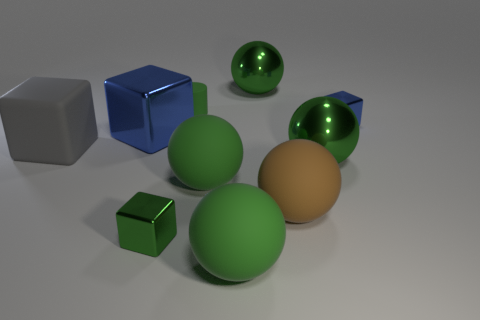Subtract all large brown rubber balls. How many balls are left? 4 Subtract all gray cubes. How many green balls are left? 4 Subtract 2 balls. How many balls are left? 3 Subtract all blue blocks. How many blocks are left? 2 Subtract all cylinders. How many objects are left? 9 Subtract all blue cylinders. Subtract all blue blocks. How many cylinders are left? 1 Subtract all tiny blue shiny objects. Subtract all blue shiny objects. How many objects are left? 7 Add 8 big gray matte cubes. How many big gray matte cubes are left? 9 Add 4 gray matte cylinders. How many gray matte cylinders exist? 4 Subtract 0 cyan cylinders. How many objects are left? 10 